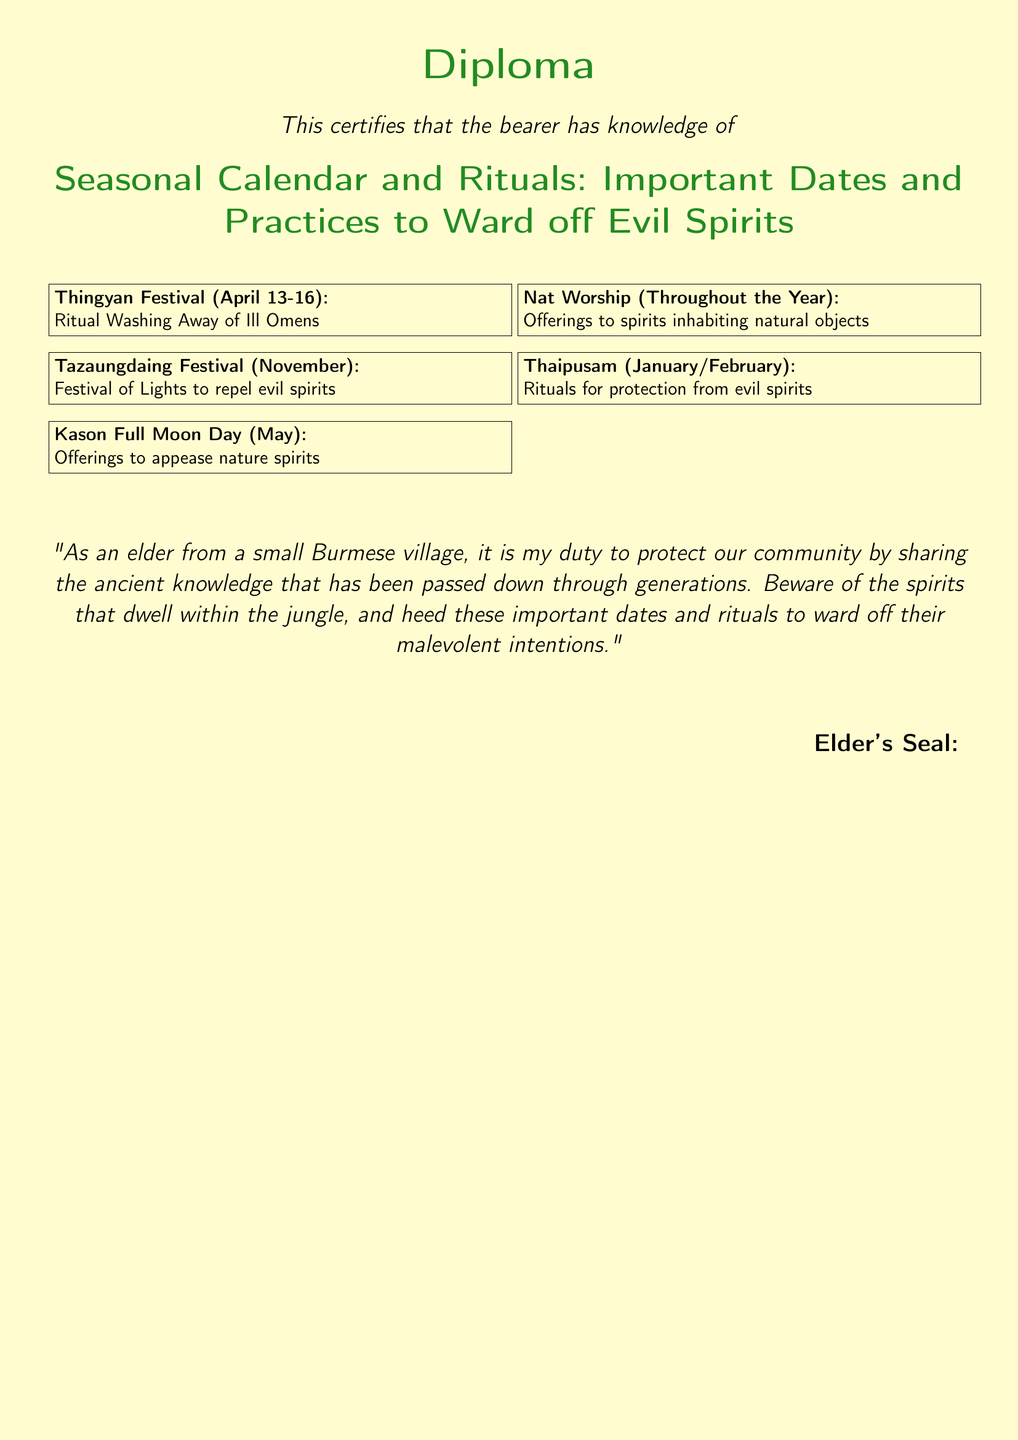What are the dates for Thingyan Festival? The Thingyan Festival occurs from April 13 to April 16, as stated in the document.
Answer: April 13-16 What does the Tazaungdaing Festival symbolize? The document indicates that the Tazaungdaing Festival is a Festival of Lights to repel evil spirits.
Answer: Festival of Lights What month does Kason Full Moon Day occur? The Kason Full Moon Day is mentioned in the document as occurring in May.
Answer: May What kind of offerings are made during Nat Worship? The document describes the Nat Worship as offering to spirits inhabiting natural objects.
Answer: Offerings to spirits What is the purpose of Thaipusam? The Thaipusam is associated with rituals for protection from evil spirits, as noted in the document.
Answer: Protection from evil spirits How many festivals are specifically listed in the document? There are five festivals mentioned in the document that are specific to the seasonal calendar and rituals.
Answer: Five What role does the elder believe they have in the community? The elder believes it is their duty to protect the community by sharing ancient knowledge.
Answer: Protect the community What is the theme of the document? The document revolves around seasonal calendar and rituals to ward off evil spirits.
Answer: Seasonal calendar and rituals 